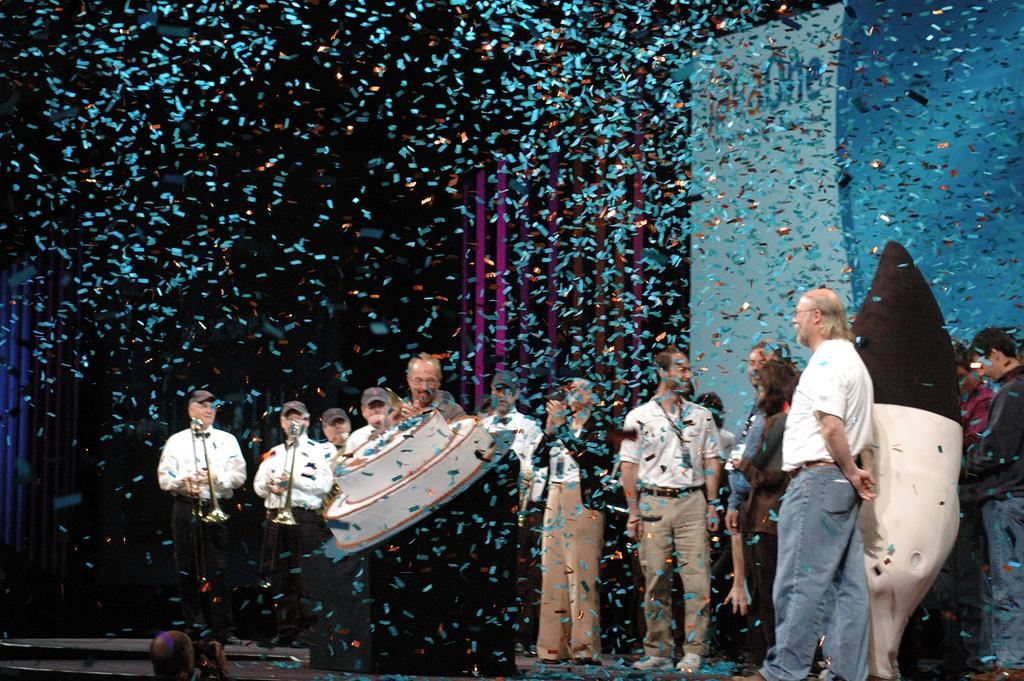How many people are in the image? There is a group of people in the image, but the exact number cannot be determined from the provided facts. What are the people in the image doing? The presence of musical instruments suggests that the people might be playing music or participating in a musical event. Can you describe any objects in the image? Yes, there are objects in the image, but their specific nature cannot be determined from the provided facts. What type of health advice can be seen on the scarecrow in the image? There is no scarecrow present in the image, so it is not possible to answer that question. 